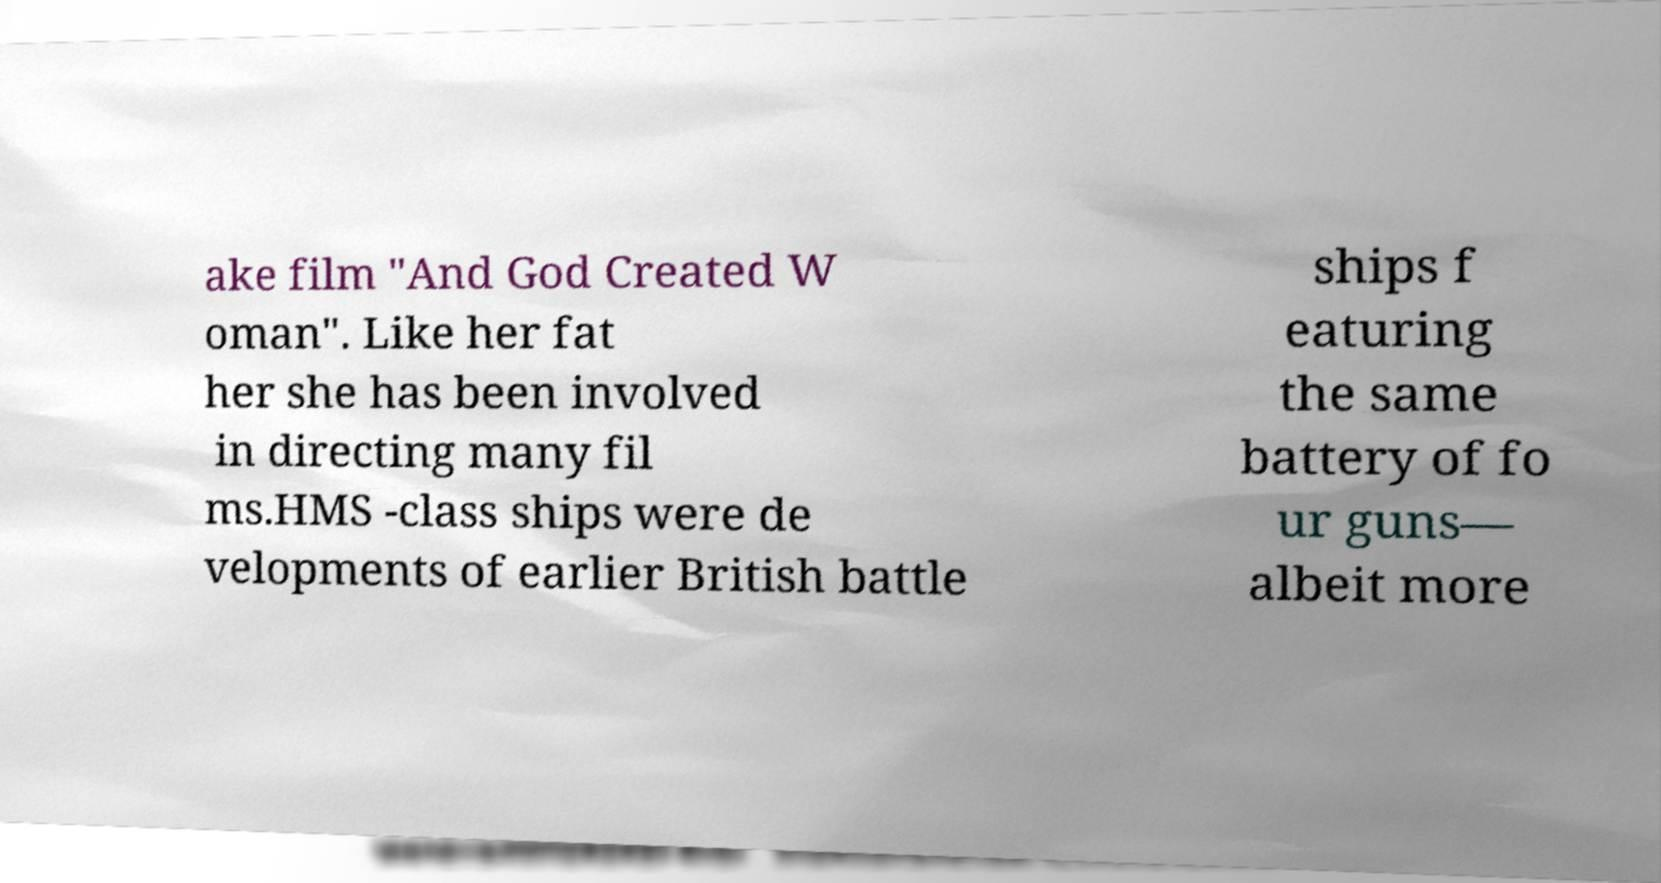Could you extract and type out the text from this image? ake film "And God Created W oman". Like her fat her she has been involved in directing many fil ms.HMS -class ships were de velopments of earlier British battle ships f eaturing the same battery of fo ur guns— albeit more 